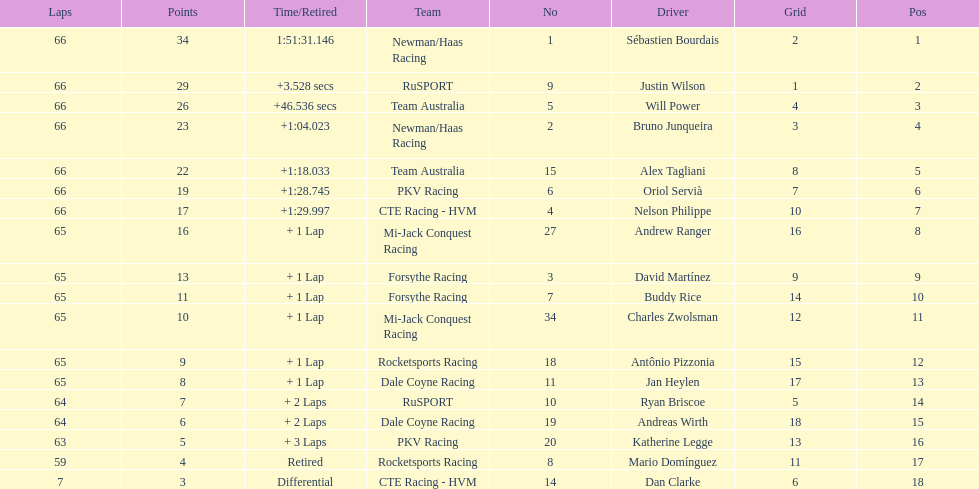Who finished directly after the driver who finished in 1:28.745? Nelson Philippe. 